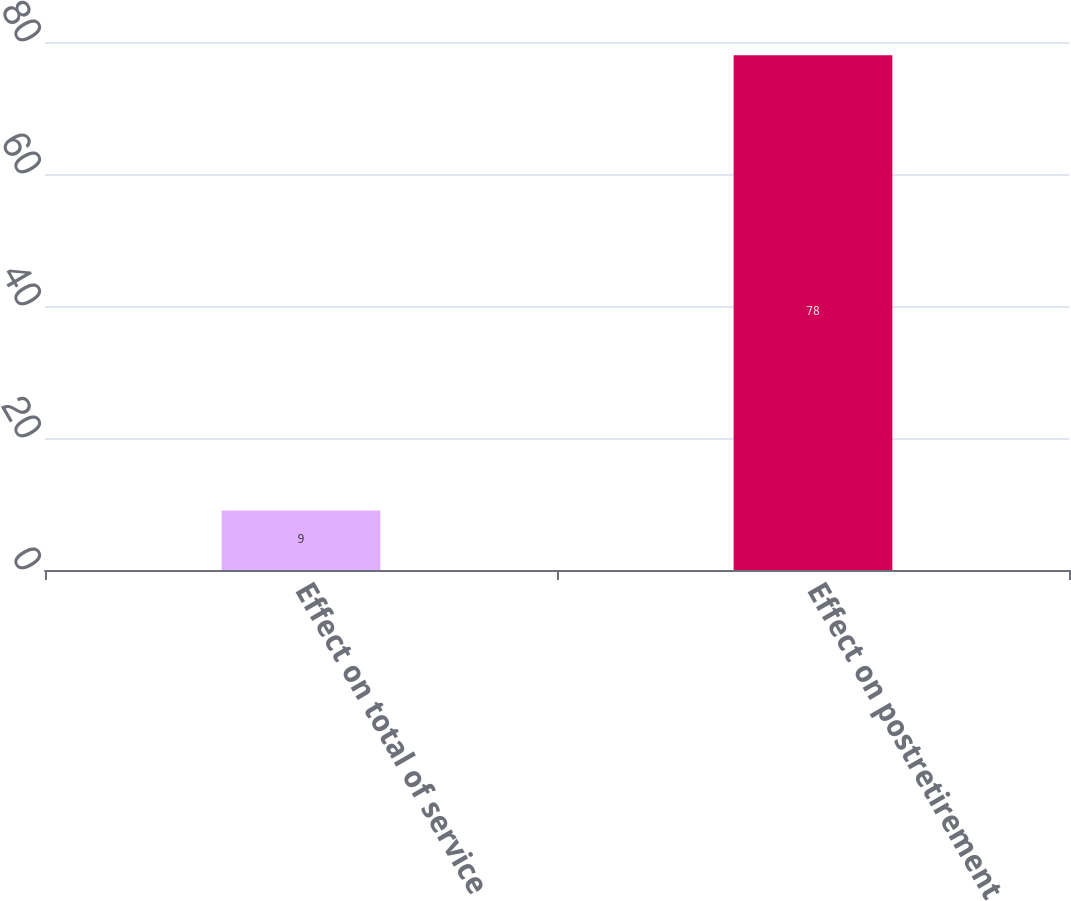Convert chart. <chart><loc_0><loc_0><loc_500><loc_500><bar_chart><fcel>Effect on total of service<fcel>Effect on postretirement<nl><fcel>9<fcel>78<nl></chart> 